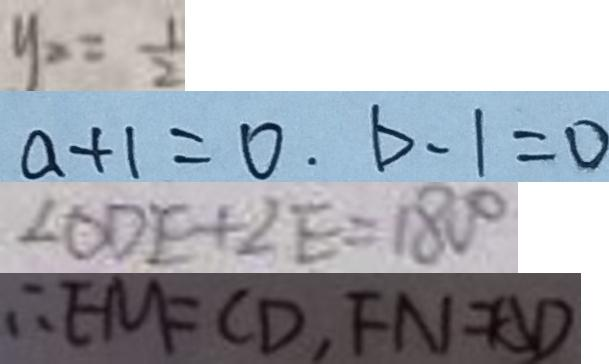<formula> <loc_0><loc_0><loc_500><loc_500>y _ { x } = \frac { 1 } { 2 } 
 a + 1 = 0 . b - 1 = 0 
 \angle O D E + \angle E = 1 8 0 ^ { \circ } 
 \therefore E M = C D , F N = A D</formula> 